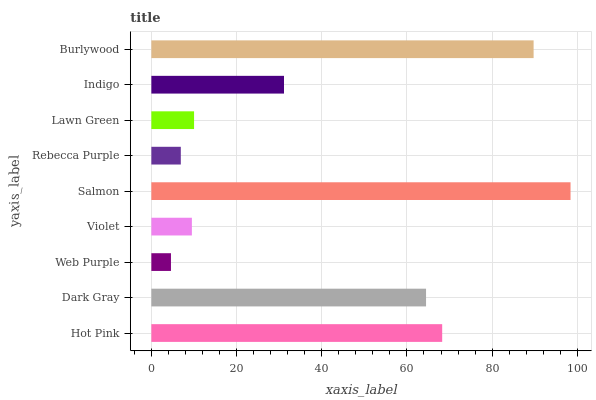Is Web Purple the minimum?
Answer yes or no. Yes. Is Salmon the maximum?
Answer yes or no. Yes. Is Dark Gray the minimum?
Answer yes or no. No. Is Dark Gray the maximum?
Answer yes or no. No. Is Hot Pink greater than Dark Gray?
Answer yes or no. Yes. Is Dark Gray less than Hot Pink?
Answer yes or no. Yes. Is Dark Gray greater than Hot Pink?
Answer yes or no. No. Is Hot Pink less than Dark Gray?
Answer yes or no. No. Is Indigo the high median?
Answer yes or no. Yes. Is Indigo the low median?
Answer yes or no. Yes. Is Hot Pink the high median?
Answer yes or no. No. Is Rebecca Purple the low median?
Answer yes or no. No. 